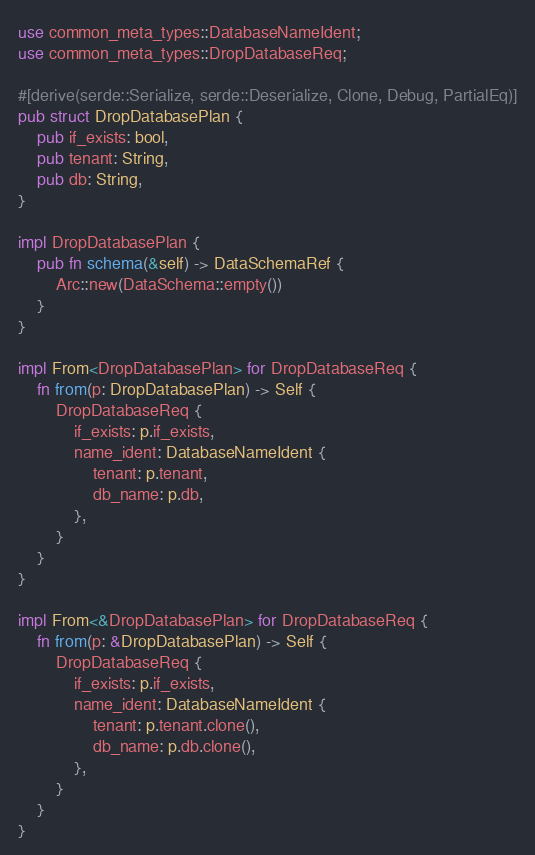Convert code to text. <code><loc_0><loc_0><loc_500><loc_500><_Rust_>use common_meta_types::DatabaseNameIdent;
use common_meta_types::DropDatabaseReq;

#[derive(serde::Serialize, serde::Deserialize, Clone, Debug, PartialEq)]
pub struct DropDatabasePlan {
    pub if_exists: bool,
    pub tenant: String,
    pub db: String,
}

impl DropDatabasePlan {
    pub fn schema(&self) -> DataSchemaRef {
        Arc::new(DataSchema::empty())
    }
}

impl From<DropDatabasePlan> for DropDatabaseReq {
    fn from(p: DropDatabasePlan) -> Self {
        DropDatabaseReq {
            if_exists: p.if_exists,
            name_ident: DatabaseNameIdent {
                tenant: p.tenant,
                db_name: p.db,
            },
        }
    }
}

impl From<&DropDatabasePlan> for DropDatabaseReq {
    fn from(p: &DropDatabasePlan) -> Self {
        DropDatabaseReq {
            if_exists: p.if_exists,
            name_ident: DatabaseNameIdent {
                tenant: p.tenant.clone(),
                db_name: p.db.clone(),
            },
        }
    }
}
</code> 